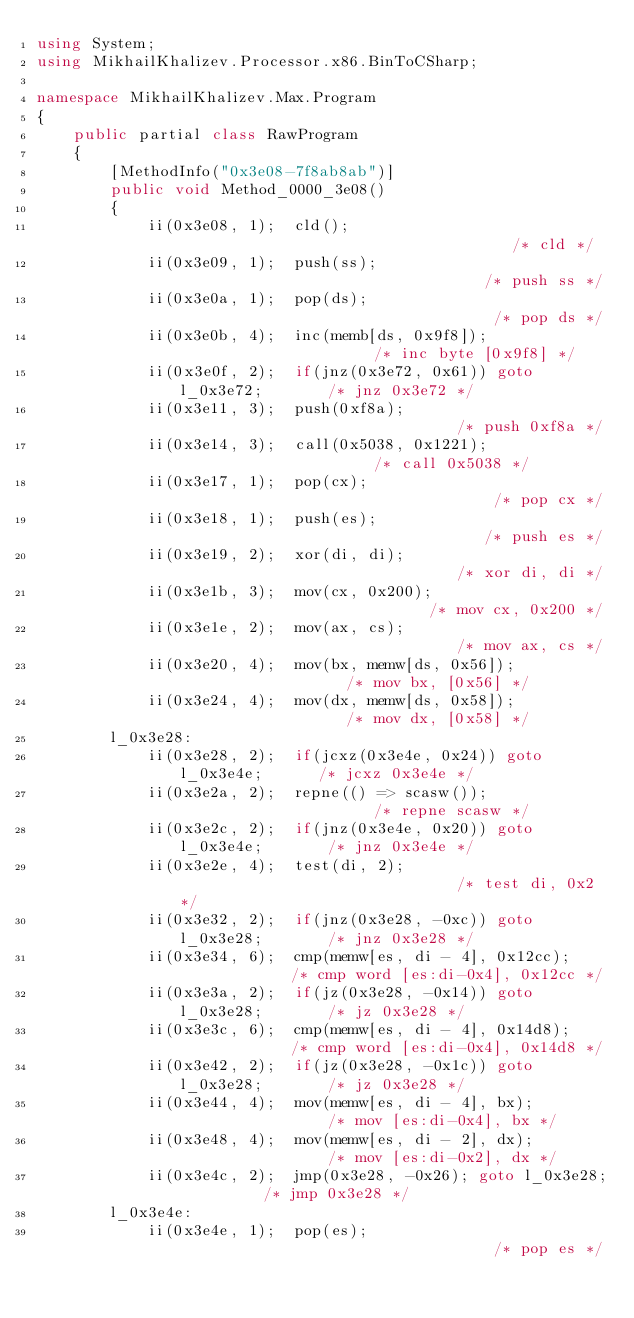<code> <loc_0><loc_0><loc_500><loc_500><_C#_>using System;
using MikhailKhalizev.Processor.x86.BinToCSharp;

namespace MikhailKhalizev.Max.Program
{
    public partial class RawProgram
    {
        [MethodInfo("0x3e08-7f8ab8ab")]
        public void Method_0000_3e08()
        {
            ii(0x3e08, 1);  cld();                                     /* cld */
            ii(0x3e09, 1);  push(ss);                                  /* push ss */
            ii(0x3e0a, 1);  pop(ds);                                   /* pop ds */
            ii(0x3e0b, 4);  inc(memb[ds, 0x9f8]);                      /* inc byte [0x9f8] */
            ii(0x3e0f, 2);  if(jnz(0x3e72, 0x61)) goto l_0x3e72;       /* jnz 0x3e72 */
            ii(0x3e11, 3);  push(0xf8a);                               /* push 0xf8a */
            ii(0x3e14, 3);  call(0x5038, 0x1221);                      /* call 0x5038 */
            ii(0x3e17, 1);  pop(cx);                                   /* pop cx */
            ii(0x3e18, 1);  push(es);                                  /* push es */
            ii(0x3e19, 2);  xor(di, di);                               /* xor di, di */
            ii(0x3e1b, 3);  mov(cx, 0x200);                            /* mov cx, 0x200 */
            ii(0x3e1e, 2);  mov(ax, cs);                               /* mov ax, cs */
            ii(0x3e20, 4);  mov(bx, memw[ds, 0x56]);                   /* mov bx, [0x56] */
            ii(0x3e24, 4);  mov(dx, memw[ds, 0x58]);                   /* mov dx, [0x58] */
        l_0x3e28:
            ii(0x3e28, 2);  if(jcxz(0x3e4e, 0x24)) goto l_0x3e4e;      /* jcxz 0x3e4e */
            ii(0x3e2a, 2);  repne(() => scasw());                      /* repne scasw */
            ii(0x3e2c, 2);  if(jnz(0x3e4e, 0x20)) goto l_0x3e4e;       /* jnz 0x3e4e */
            ii(0x3e2e, 4);  test(di, 2);                               /* test di, 0x2 */
            ii(0x3e32, 2);  if(jnz(0x3e28, -0xc)) goto l_0x3e28;       /* jnz 0x3e28 */
            ii(0x3e34, 6);  cmp(memw[es, di - 4], 0x12cc);             /* cmp word [es:di-0x4], 0x12cc */
            ii(0x3e3a, 2);  if(jz(0x3e28, -0x14)) goto l_0x3e28;       /* jz 0x3e28 */
            ii(0x3e3c, 6);  cmp(memw[es, di - 4], 0x14d8);             /* cmp word [es:di-0x4], 0x14d8 */
            ii(0x3e42, 2);  if(jz(0x3e28, -0x1c)) goto l_0x3e28;       /* jz 0x3e28 */
            ii(0x3e44, 4);  mov(memw[es, di - 4], bx);                 /* mov [es:di-0x4], bx */
            ii(0x3e48, 4);  mov(memw[es, di - 2], dx);                 /* mov [es:di-0x2], dx */
            ii(0x3e4c, 2);  jmp(0x3e28, -0x26); goto l_0x3e28;         /* jmp 0x3e28 */
        l_0x3e4e:
            ii(0x3e4e, 1);  pop(es);                                   /* pop es */</code> 